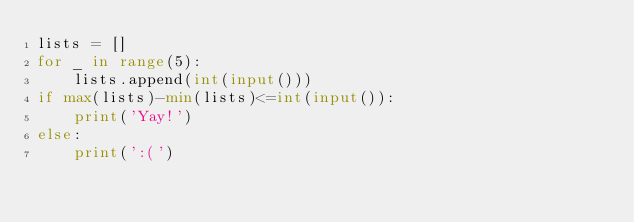Convert code to text. <code><loc_0><loc_0><loc_500><loc_500><_Python_>lists = []
for _ in range(5):
    lists.append(int(input()))
if max(lists)-min(lists)<=int(input()):
    print('Yay!')
else:
    print(':(')</code> 